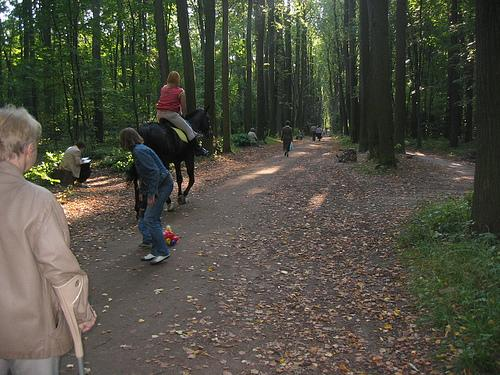What is helping someone walk? Please explain your reasoning. crutches. The crutches allow the person to walk. 